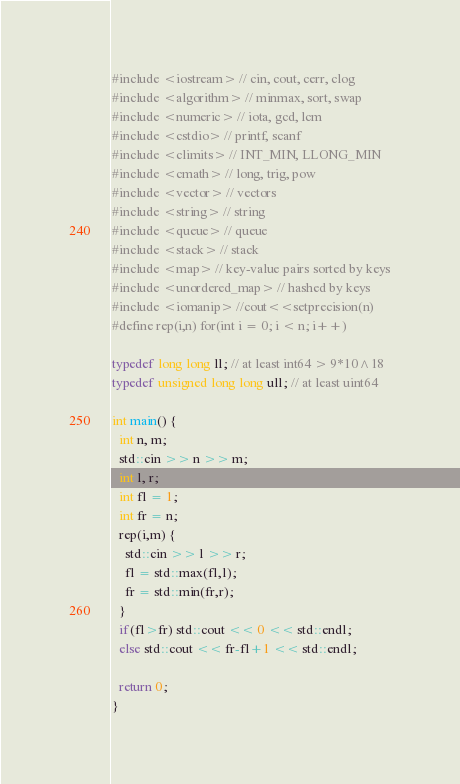<code> <loc_0><loc_0><loc_500><loc_500><_C++_>#include <iostream> // cin, cout, cerr, clog
#include <algorithm> // minmax, sort, swap
#include <numeric> // iota, gcd, lcm 
#include <cstdio> // printf, scanf
#include <climits> // INT_MIN, LLONG_MIN
#include <cmath> // long, trig, pow
#include <vector> // vectors
#include <string> // string
#include <queue> // queue
#include <stack> // stack
#include <map> // key-value pairs sorted by keys
#include <unordered_map> // hashed by keys
#include <iomanip> //cout<<setprecision(n)
#define rep(i,n) for(int i = 0; i < n; i++)

typedef long long ll; // at least int64 > 9*10^18
typedef unsigned long long ull; // at least uint64

int main() {
  int n, m;
  std::cin >> n >> m;
  int l, r;
  int fl = 1;
  int fr = n;
  rep(i,m) {
    std::cin >> l >> r;
    fl = std::max(fl,l);
    fr = std::min(fr,r);
  }
  if(fl>fr) std::cout << 0 << std::endl;
  else std::cout << fr-fl+1 << std::endl;
  
  return 0;
}</code> 